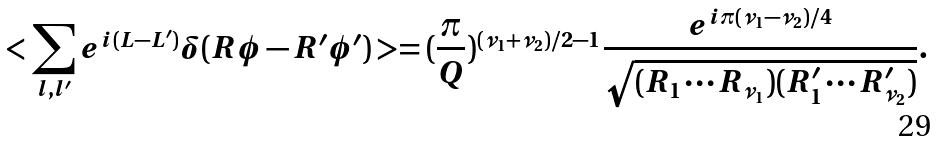Convert formula to latex. <formula><loc_0><loc_0><loc_500><loc_500>< \sum _ { l , l ^ { \prime } } e ^ { i ( L - L ^ { \prime } ) } \delta ( R \phi - R ^ { \prime } \phi ^ { \prime } ) > = ( \frac { \pi } { Q } ) ^ { ( \nu _ { 1 } + \nu _ { 2 } ) / 2 - 1 } \frac { e ^ { i \pi ( \nu _ { 1 } - \nu _ { 2 } ) / 4 } } { \sqrt { ( R _ { 1 } \cdots R _ { \nu _ { 1 } } ) ( R _ { 1 } ^ { \prime } \cdots R _ { \nu _ { 2 } } ^ { \prime } ) } } .</formula> 